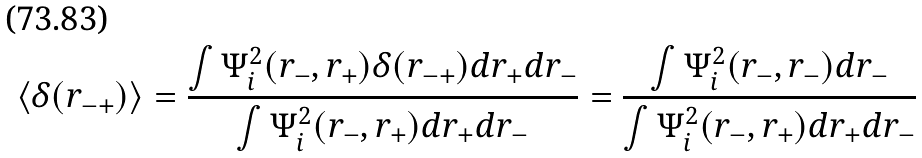Convert formula to latex. <formula><loc_0><loc_0><loc_500><loc_500>\langle \delta ( r _ { - + } ) \rangle = \frac { \int \Psi _ { i } ^ { 2 } ( r _ { - } , r _ { + } ) \delta ( r _ { - + } ) d r _ { + } d r _ { - } } { \int \Psi _ { i } ^ { 2 } ( r _ { - } , r _ { + } ) d r _ { + } d r _ { - } } = \frac { \int \Psi _ { i } ^ { 2 } ( r _ { - } , r _ { - } ) d r _ { - } } { \int \Psi _ { i } ^ { 2 } ( r _ { - } , r _ { + } ) d r _ { + } d r _ { - } }</formula> 